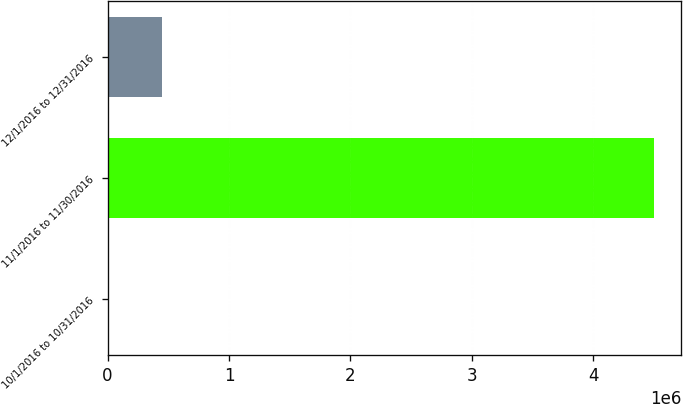Convert chart. <chart><loc_0><loc_0><loc_500><loc_500><bar_chart><fcel>10/1/2016 to 10/31/2016<fcel>11/1/2016 to 11/30/2016<fcel>12/1/2016 to 12/31/2016<nl><fcel>1.34<fcel>4.50067e+06<fcel>450068<nl></chart> 